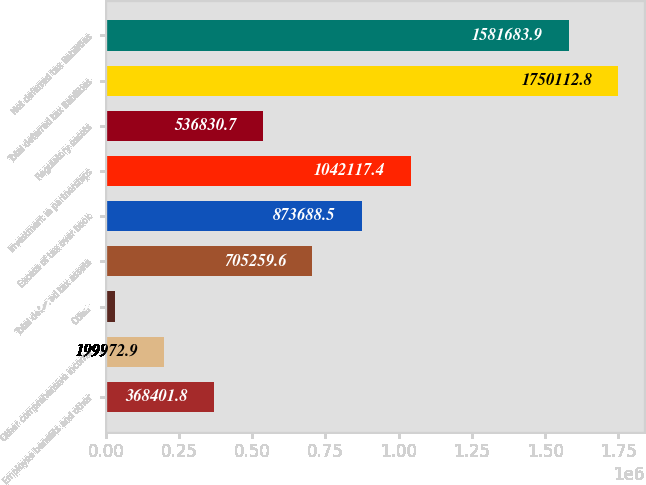Convert chart to OTSL. <chart><loc_0><loc_0><loc_500><loc_500><bar_chart><fcel>Employee benefits and other<fcel>Other comprehensive income<fcel>Other<fcel>Total deferred tax assets<fcel>Excess of tax over book<fcel>Investment in partnerships<fcel>Regulatory assets<fcel>Total deferred tax liabilities<fcel>Net deferred tax liabilities<nl><fcel>368402<fcel>199973<fcel>31544<fcel>705260<fcel>873688<fcel>1.04212e+06<fcel>536831<fcel>1.75011e+06<fcel>1.58168e+06<nl></chart> 